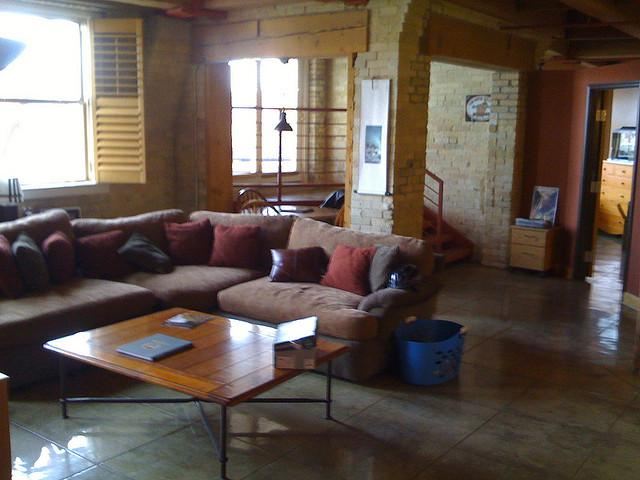What is on the table? Please explain your reasoning. book. There is a book on the coffee table. 